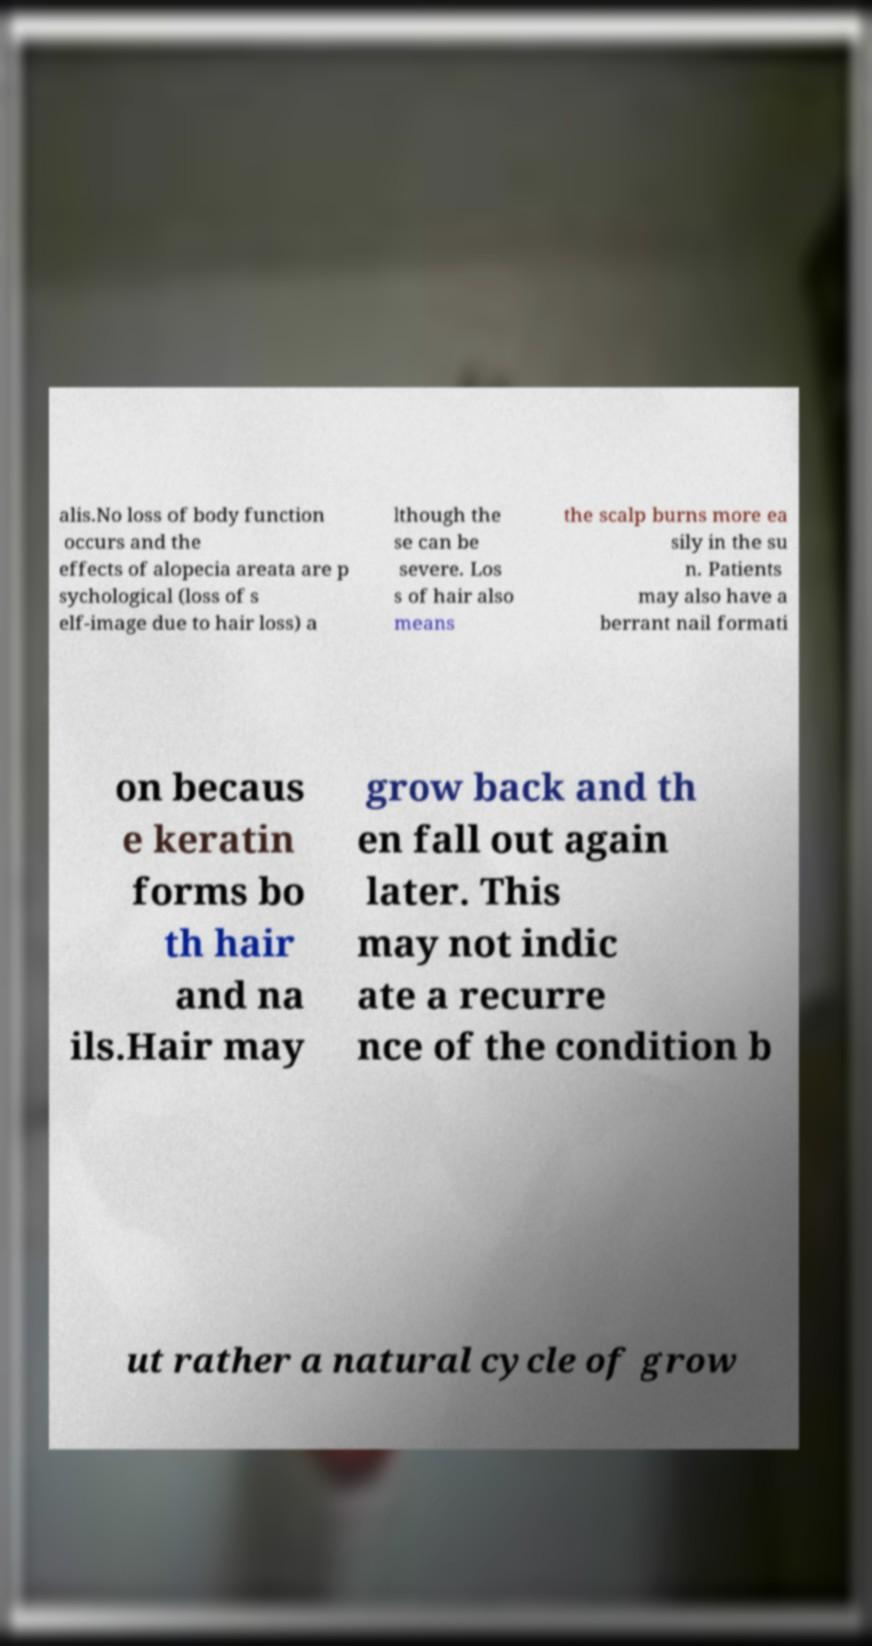Could you extract and type out the text from this image? alis.No loss of body function occurs and the effects of alopecia areata are p sychological (loss of s elf-image due to hair loss) a lthough the se can be severe. Los s of hair also means the scalp burns more ea sily in the su n. Patients may also have a berrant nail formati on becaus e keratin forms bo th hair and na ils.Hair may grow back and th en fall out again later. This may not indic ate a recurre nce of the condition b ut rather a natural cycle of grow 